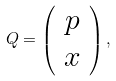<formula> <loc_0><loc_0><loc_500><loc_500>Q = \left ( \begin{array} { c } p \\ x \end{array} \right ) ,</formula> 